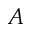Convert formula to latex. <formula><loc_0><loc_0><loc_500><loc_500>{ A }</formula> 